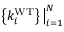<formula> <loc_0><loc_0><loc_500><loc_500>\left \{ k _ { i } ^ { W T } \right \} \Big | _ { i = 1 } ^ { N }</formula> 